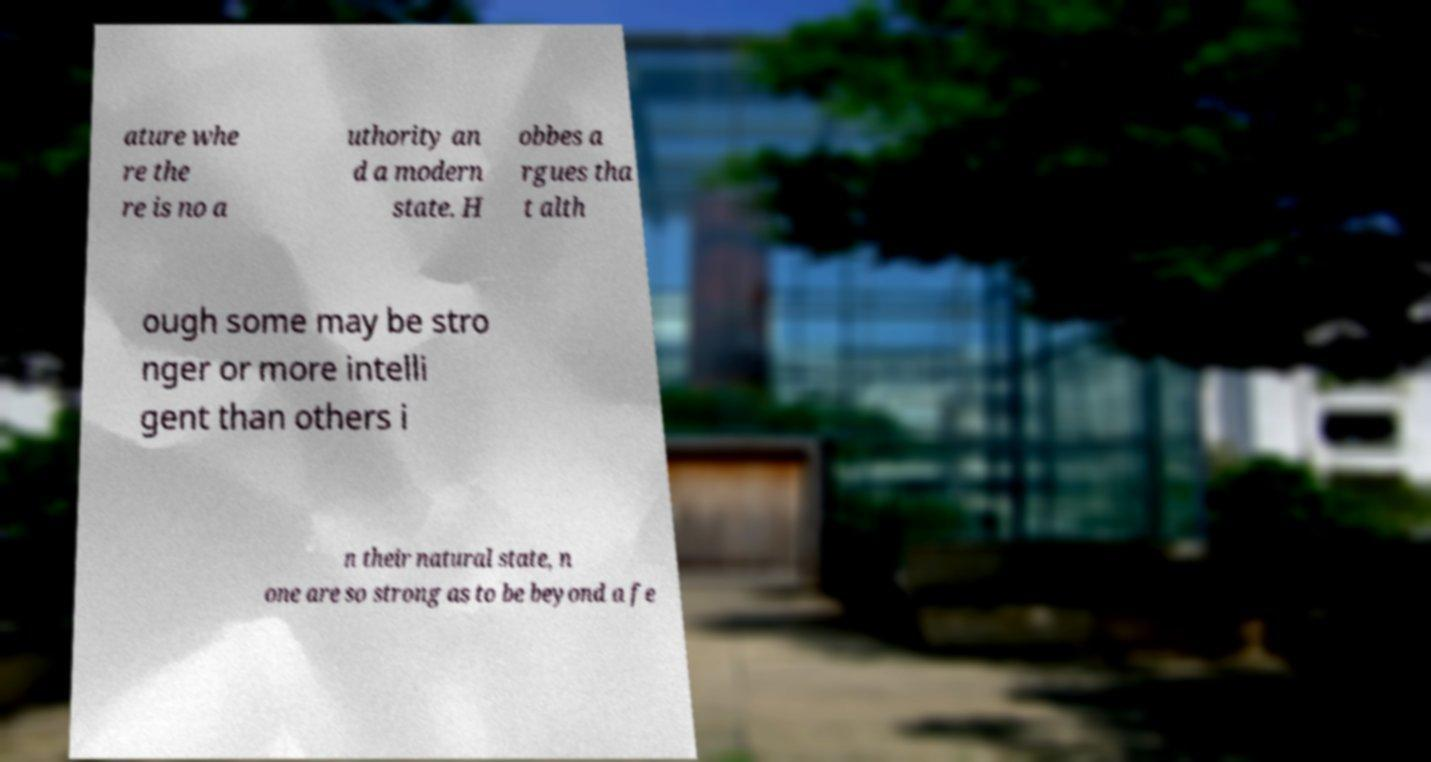What messages or text are displayed in this image? I need them in a readable, typed format. ature whe re the re is no a uthority an d a modern state. H obbes a rgues tha t alth ough some may be stro nger or more intelli gent than others i n their natural state, n one are so strong as to be beyond a fe 